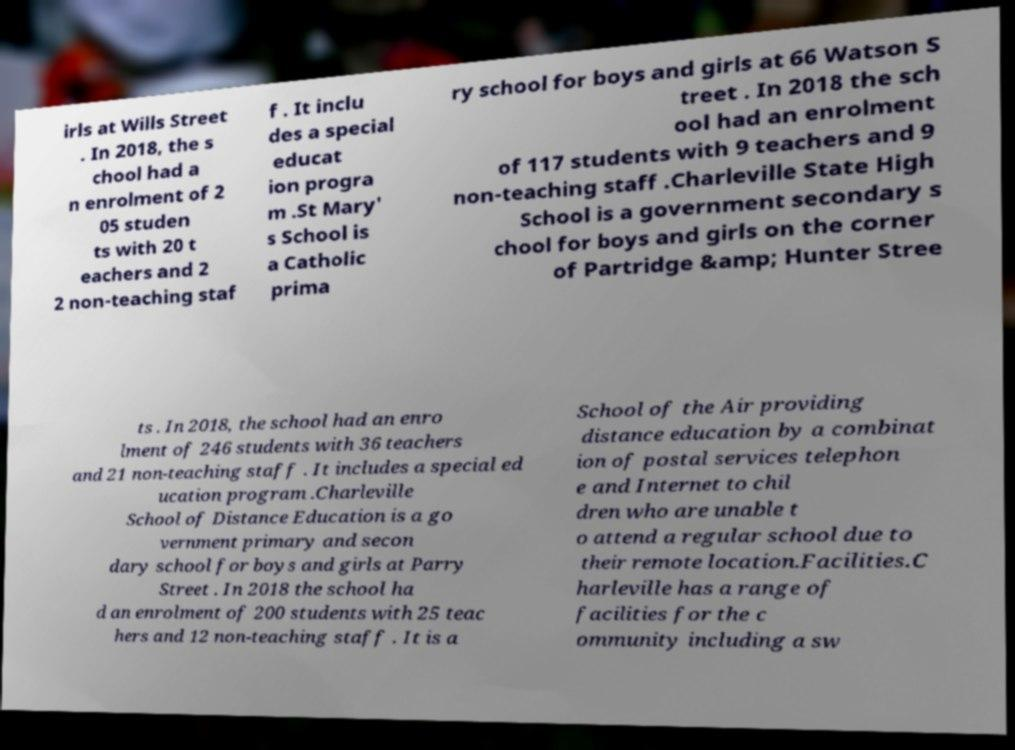Please read and relay the text visible in this image. What does it say? irls at Wills Street . In 2018, the s chool had a n enrolment of 2 05 studen ts with 20 t eachers and 2 2 non-teaching staf f . It inclu des a special educat ion progra m .St Mary' s School is a Catholic prima ry school for boys and girls at 66 Watson S treet . In 2018 the sch ool had an enrolment of 117 students with 9 teachers and 9 non-teaching staff .Charleville State High School is a government secondary s chool for boys and girls on the corner of Partridge &amp; Hunter Stree ts . In 2018, the school had an enro lment of 246 students with 36 teachers and 21 non-teaching staff . It includes a special ed ucation program .Charleville School of Distance Education is a go vernment primary and secon dary school for boys and girls at Parry Street . In 2018 the school ha d an enrolment of 200 students with 25 teac hers and 12 non-teaching staff . It is a School of the Air providing distance education by a combinat ion of postal services telephon e and Internet to chil dren who are unable t o attend a regular school due to their remote location.Facilities.C harleville has a range of facilities for the c ommunity including a sw 